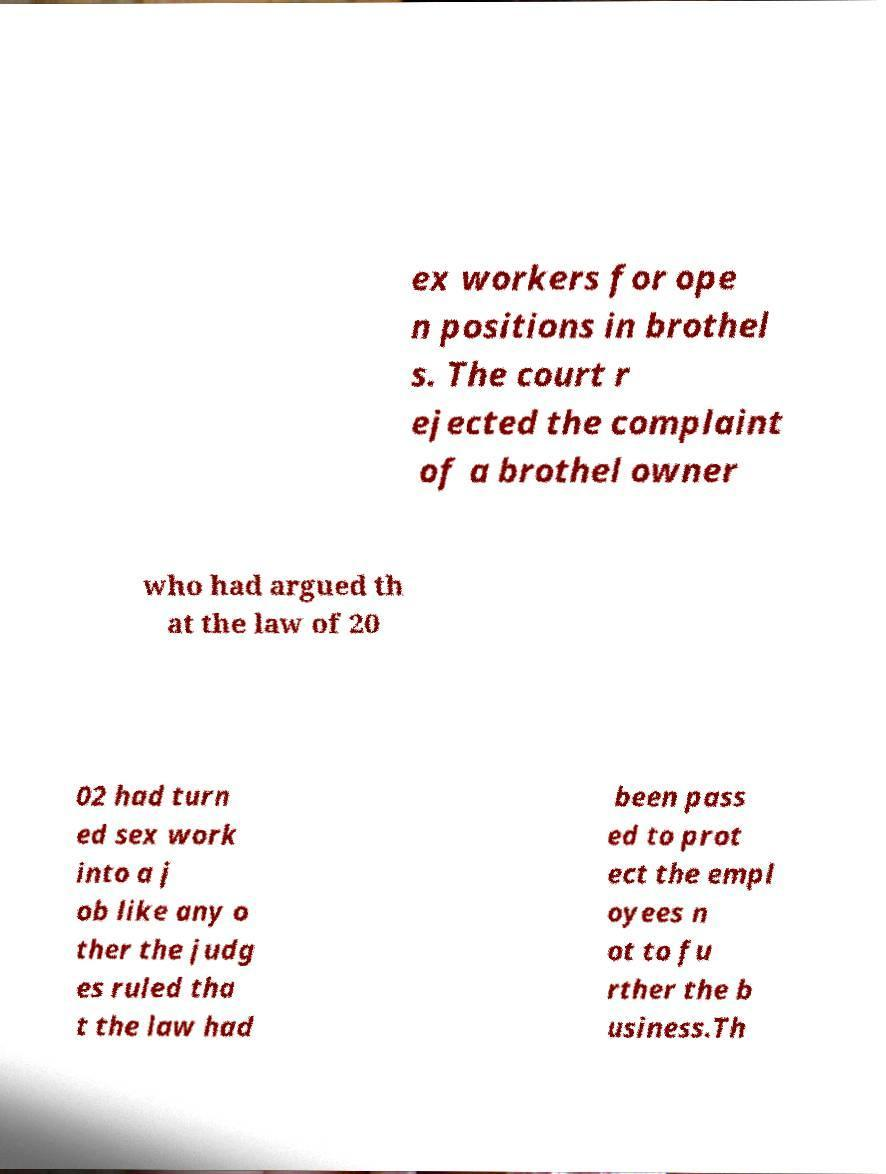Please read and relay the text visible in this image. What does it say? ex workers for ope n positions in brothel s. The court r ejected the complaint of a brothel owner who had argued th at the law of 20 02 had turn ed sex work into a j ob like any o ther the judg es ruled tha t the law had been pass ed to prot ect the empl oyees n ot to fu rther the b usiness.Th 